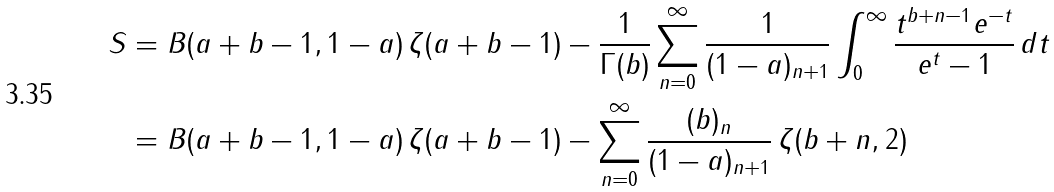<formula> <loc_0><loc_0><loc_500><loc_500>S & = B ( a + b - 1 , 1 - a ) \, \zeta ( a + b - 1 ) - \frac { 1 } { \Gamma ( b ) } \sum _ { n = 0 } ^ { \infty } \frac { 1 } { ( 1 - a ) _ { n + 1 } } \int _ { 0 } ^ { \infty } \frac { t ^ { b + n - 1 } e ^ { - t } } { e ^ { t } - 1 } \, d t \\ & = B ( a + b - 1 , 1 - a ) \, \zeta ( a + b - 1 ) - \sum _ { n = 0 } ^ { \infty } \frac { ( b ) _ { n } } { ( 1 - a ) _ { n + 1 } } \, \zeta ( b + n , 2 )</formula> 